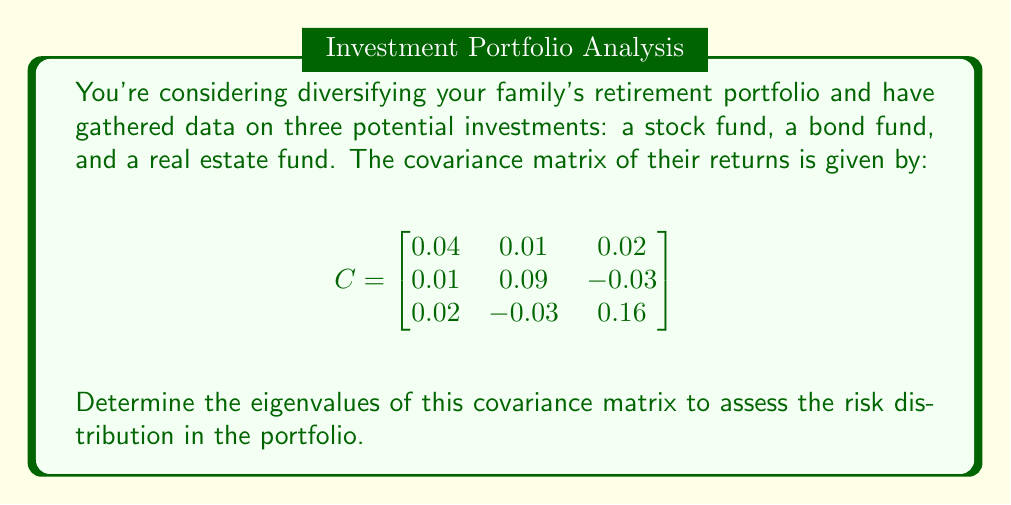What is the answer to this math problem? To find the eigenvalues of the covariance matrix, we need to solve the characteristic equation:

$$\det(C - \lambda I) = 0$$

where $I$ is the 3x3 identity matrix and $\lambda$ represents the eigenvalues.

Step 1: Set up the characteristic equation:

$$
\det\begin{pmatrix}
0.04 - \lambda & 0.01 & 0.02 \\
0.01 & 0.09 - \lambda & -0.03 \\
0.02 & -0.03 & 0.16 - \lambda
\end{pmatrix} = 0
$$

Step 2: Expand the determinant:

$$(0.04 - \lambda)[(0.09 - \lambda)(0.16 - \lambda) + 0.0009] + 0.01[0.02(0.16 - \lambda) + 0.0006] + 0.02[0.01(0.16 - \lambda) - 0.03(0.09 - \lambda)] = 0$$

Step 3: Simplify:

$$-\lambda^3 + 0.29\lambda^2 - 0.0269\lambda + 0.000676 = 0$$

Step 4: Solve this cubic equation. The roots of this equation are the eigenvalues. Using a numerical method or computer algebra system, we find the roots:

$$\lambda_1 \approx 0.1825$$
$$\lambda_2 \approx 0.0858$$
$$\lambda_3 \approx 0.0217$$

These eigenvalues represent the principal variances of the portfolio, with the largest eigenvalue indicating the direction of maximum variability in the investment returns.
Answer: $\lambda_1 \approx 0.1825$, $\lambda_2 \approx 0.0858$, $\lambda_3 \approx 0.0217$ 